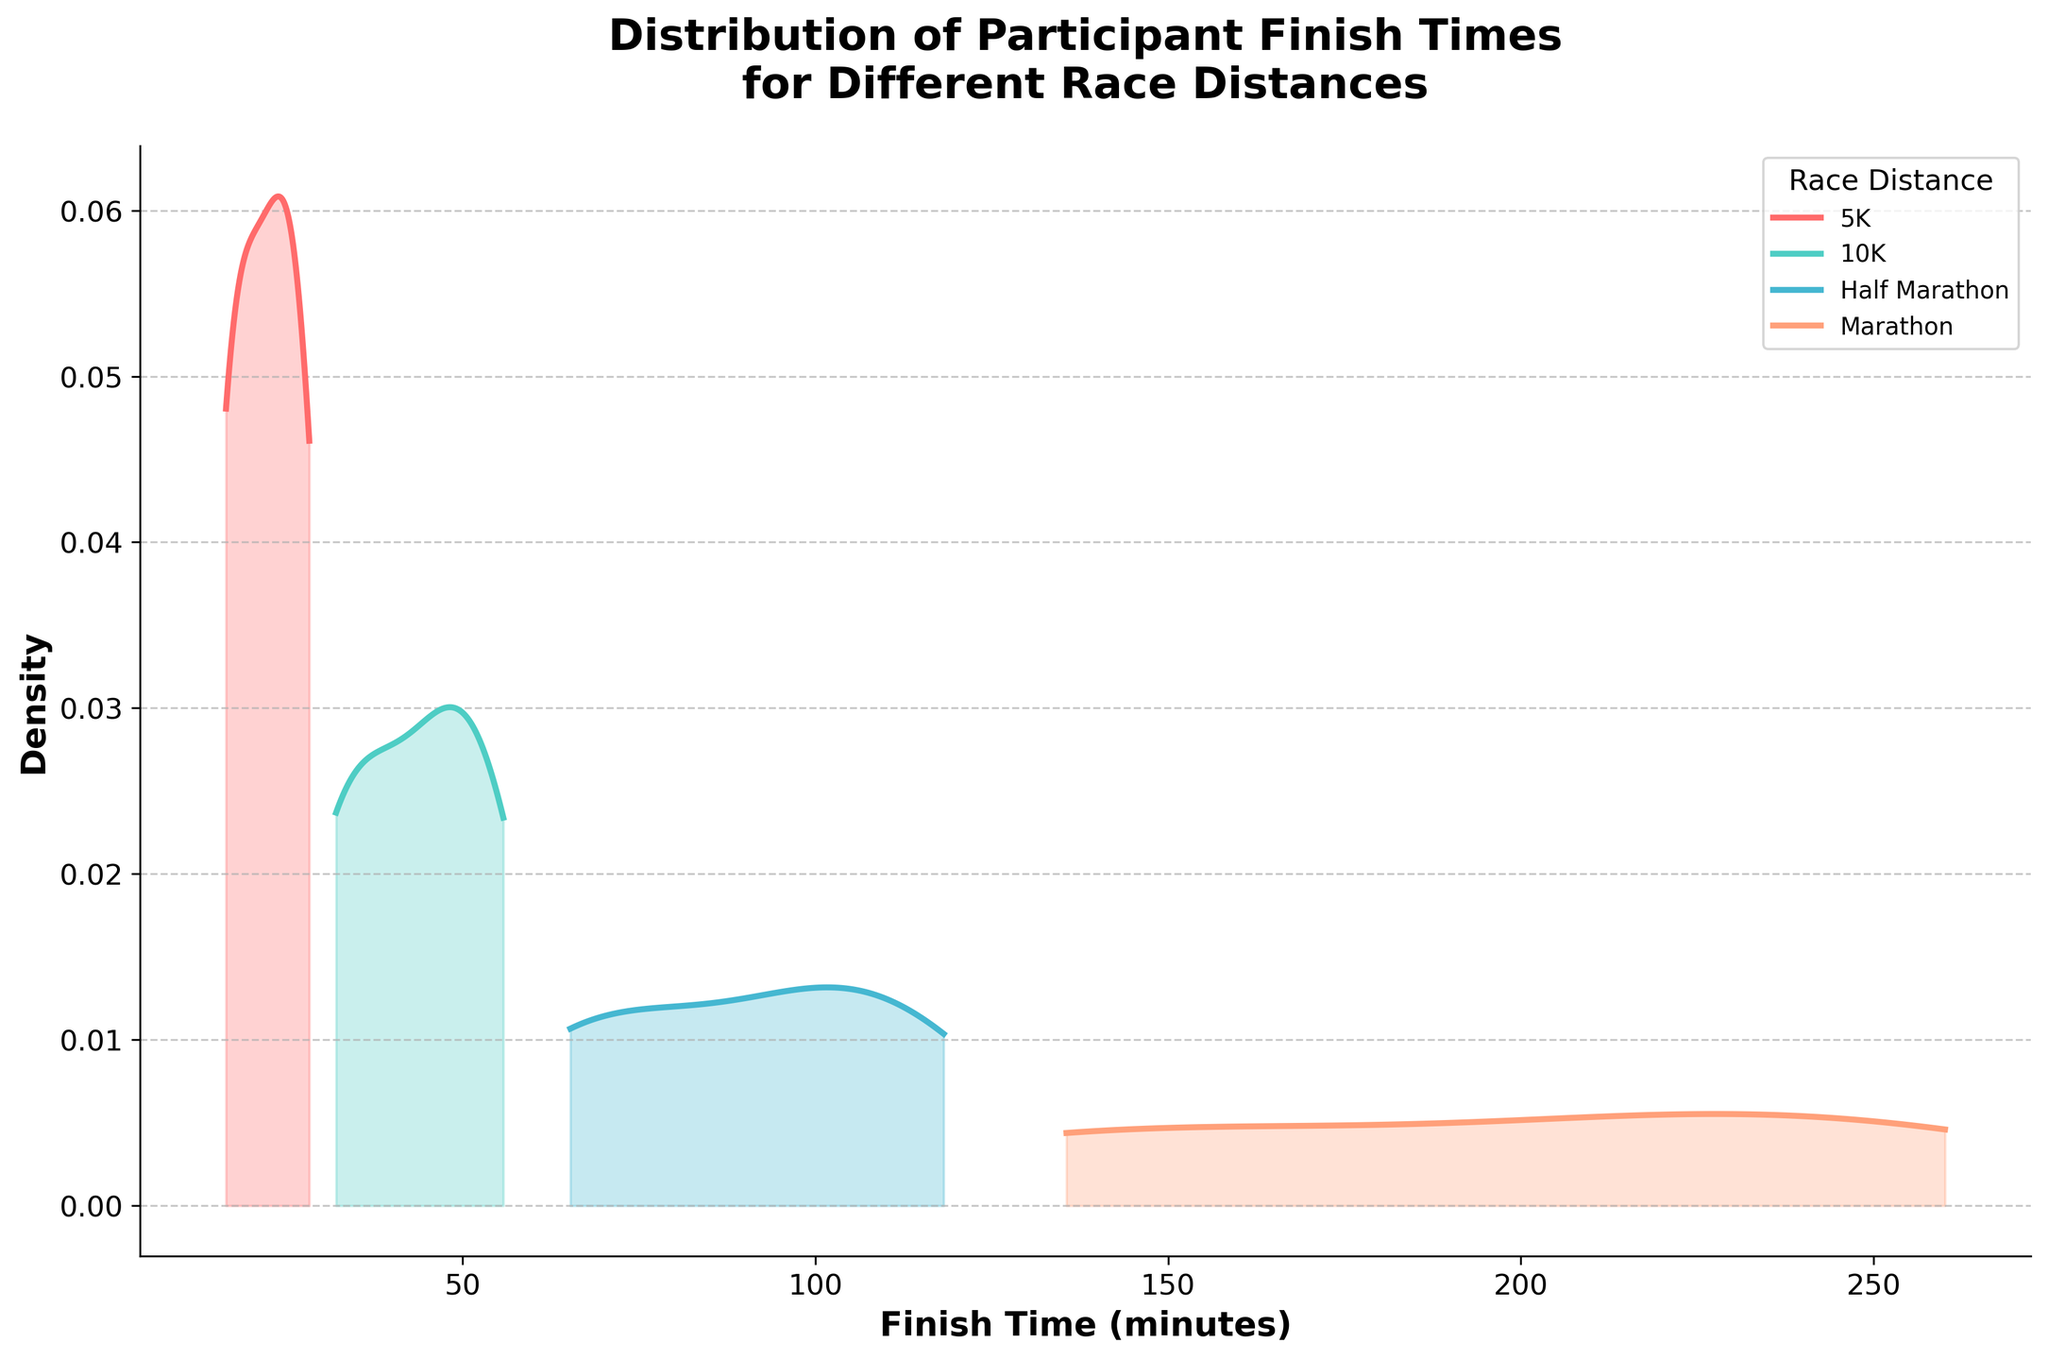What is the title of this plot? Look at the top section of the plot where the title is typically displayed. The title provided indicates the subject of the plot.
Answer: Distribution of Participant Finish Times for Different Race Distances Which axis represents the finish time? Examine the labels on both axes. The label indicating "Finish Time (minutes)" specifies the axis representing the finish time.
Answer: The x-axis Which race distance has the densest peak for elite runners? Observe each curve and identify the one with the highest peak corresponding to a shorter finish time for elite runners. The color and label for each distance help in differentiation.
Answer: 5K How do the finish times of elite participants in the Half Marathon compare to those in the Marathon? Compare the position of the peaks corresponding to elite runners in both the Half Marathon and Marathon. Look for the finish times where the peaks occur for each.
Answer: Elite participants in the Half Marathon finish quicker than those in the Marathon Is there a noticeable difference between elite and average runners for each distance? Look at the separation between the peaks of elite and average finish times for each distance. A noticeable gap indicates a difference.
Answer: Yes Which category of runners has a more spread-out (less dense) distribution of finish times in the Marathon? Examine the width and height of the curves for elite and average runners in the Marathon. A less dense curve that spreads out more indicates more variability in finish times.
Answer: Average runners At what approximate finish time does the peak for average participants running the 10K occur? Identify the highest point in the density plot for average participants running the 10K. Then, locate the x-axis value aligned with this peak.
Answer: Approximately 50 minutes Are there evident separations between elite and average runners within each race distance? Look for differences in peak positions and curve overlaps between elite and average runners for each race distance. The separations indicate distinctions.
Answer: Yes What can you infer about the performance consistency of elite runners across different distances? Observe the peak sharpness and positions within the elite curves across all race distances. Tighter peaks suggest more consistent performance.
Answer: Elite runners show consistent performance across distances 